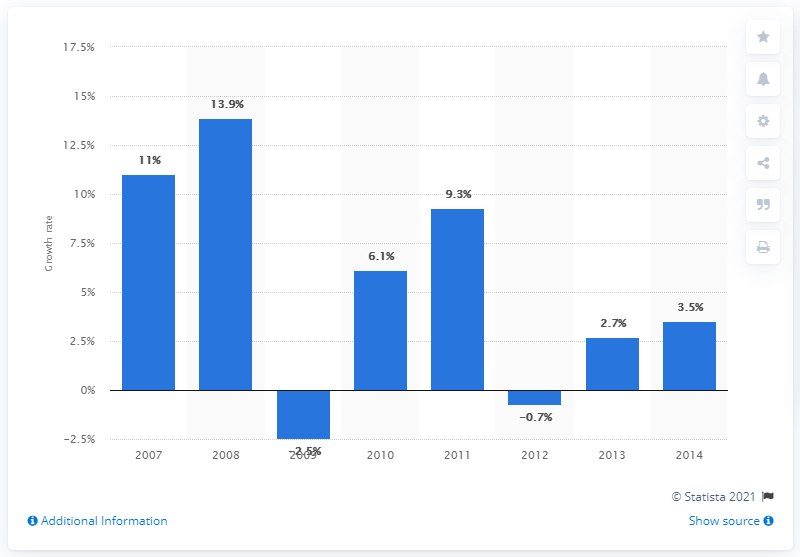Give some essential details in this illustration. The pharmaceutical industry's wages and salaries increased by 13.9% from 2007 to 2008. 